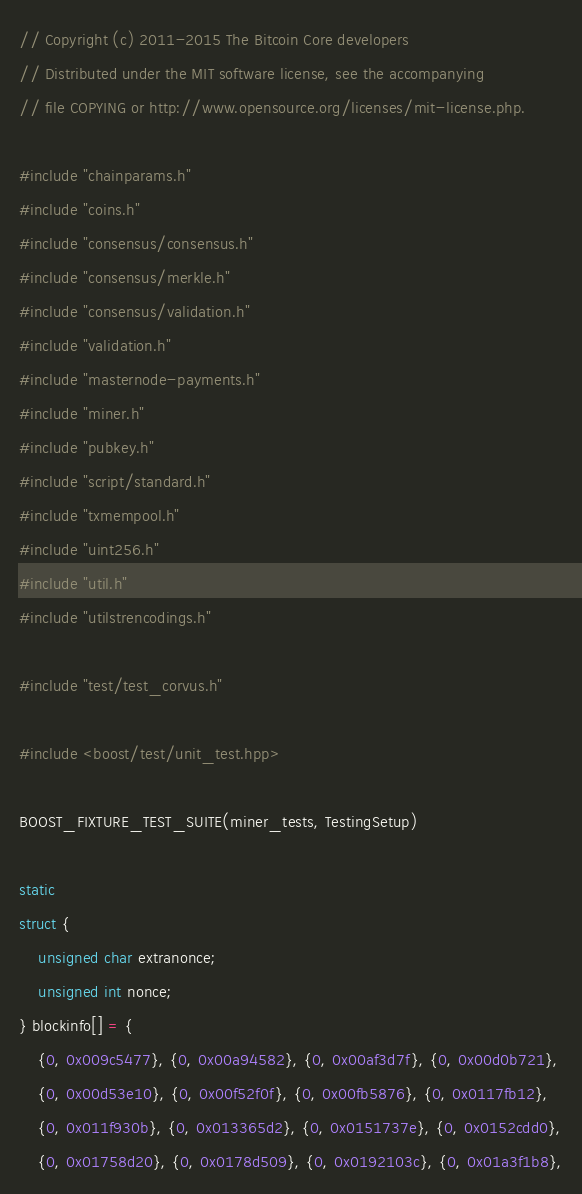<code> <loc_0><loc_0><loc_500><loc_500><_C++_>// Copyright (c) 2011-2015 The Bitcoin Core developers
// Distributed under the MIT software license, see the accompanying
// file COPYING or http://www.opensource.org/licenses/mit-license.php.

#include "chainparams.h"
#include "coins.h"
#include "consensus/consensus.h"
#include "consensus/merkle.h"
#include "consensus/validation.h"
#include "validation.h"
#include "masternode-payments.h"
#include "miner.h"
#include "pubkey.h"
#include "script/standard.h"
#include "txmempool.h"
#include "uint256.h"
#include "util.h"
#include "utilstrencodings.h"

#include "test/test_corvus.h"

#include <boost/test/unit_test.hpp>

BOOST_FIXTURE_TEST_SUITE(miner_tests, TestingSetup)

static
struct {
    unsigned char extranonce;
    unsigned int nonce;
} blockinfo[] = {
    {0, 0x009c5477}, {0, 0x00a94582}, {0, 0x00af3d7f}, {0, 0x00d0b721},
    {0, 0x00d53e10}, {0, 0x00f52f0f}, {0, 0x00fb5876}, {0, 0x0117fb12},
    {0, 0x011f930b}, {0, 0x013365d2}, {0, 0x0151737e}, {0, 0x0152cdd0},
    {0, 0x01758d20}, {0, 0x0178d509}, {0, 0x0192103c}, {0, 0x01a3f1b8},</code> 